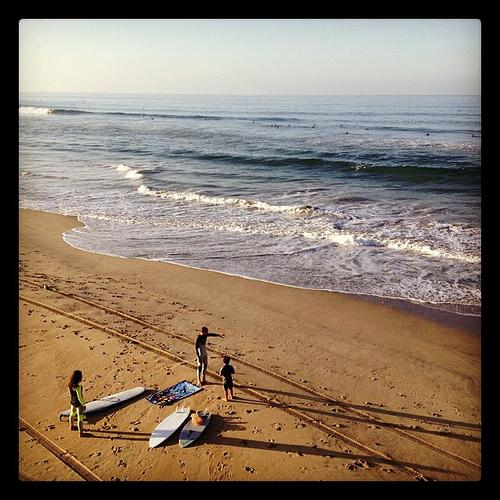Analyze the mood or sentiment of the image. The image evokes a relaxing and peaceful mood, with people enjoying a day at the beach amidst the beautiful natural setting. Count the total number of surfboards visible in the image. There are five surfboards in the image, including three white surfboards placed in the sand and two longer surfboards nearby. Identify the primary setting of the image. The image is set at a beach with a blue sky, clouds, sea water, and sand. Identify what the people are wearing while standing near the surfboard. One person is wearing a yellow wetsuit, another in a white and black wetsuit, and a child is wearing surfing clothes. Describe the interactions between the people and the surfboards. The three persons are standing near a surfboard, with a man talking to a child, and another person standing next to the towel near the surfboards. A person is pointing their arm towards the distance. What is happening in the ocean waters in the image? There are waves crashing in the sea water, birds in the calm ocean, and white waters coming into the shore with the tide. How many people can be seen on the beach? There are five people at the beach, including three standing near the surfboard, a person standing next to the towel, and a person standing near the two surfboards. Describe the scene involving the surfers and their surfboards. Three persons are standing near a surfboard with one surfer in a yellow wetsuit, another in a white and black wetsuit, and a little boy wearing surfing clothes. There are two white surfboards and a white surfboard in the sand nearby. What type of weather is shown in the image? It's a partly cloudy day with a blue sky and some clouds. What are the different objects that can be seen on the sand? There are surfboards, footprints, towel, a beach towel, a lone bird, and a little boy wearing surfing clothes on the sand. List all the objects in the image and their attributes. blue sky with clouds, surfboards in sand, sea water, waves, three persons, foot steps, yellow wetsuit surfer, white and black wetsuit surfer, birds in ocean, beach towel, little boy in surfing clothes, man's arm pointing. Locate the group of dolphins playfully swimming in the deeper part of the ocean. No, it's not mentioned in the image. Are there any texts visible in the image? If so, describe them. No, there are no texts visible in the image. Describe the different segments in the image according to their appearance. Sky, beach, ocean with waves, people with surfboards, footprints in the sand. Find out which object best describes the condition of the ocean in this image. The waves in the sea water and the white waters in the ocean. What kind of clothing are the people in the image wearing? Surfing clothes, wetsuits, casual beach attire. Describe the color and size attributes of the surfboards. White surfboards of various sizes, two primarily large ones in focus. Are there any unnatural occurrences or oddities within the image? No, there are no unnatural occurrences or oddities. Is the image clear and well-lit for comprehension? Yes, the image is clear and well-lit. What captions could be used to uniquely identify the surfboard in the sand? "a white surfboard in the sand", "the longest surfboard on the sand", "the item on the surfboard"  what object in the image conveys the most enjoyable and peaceful part The blue color sky with clouds conveys a peaceful atmosphere and the people with surfboards convey enjoyment. Identify the main actions of the people in the image. Standing, talking, pointing, holding surfboards. Describe the image with a single sentence. The image shows people and surfboards on a beach with footprints in the sand and blue sky with clouds above the sea. In what section of the image is the little boy wearing surfing clothes located? Bottom right section, coordinates X:214 Y:353 Width:31 Height:31. Which objects in the image are closest to the sea? Birds in the calm ocean, waves in the sea water, and the tide coming into the shore. What kind of emotions and mood does the scene in the image convey? Relaxation, enjoyment, and a peaceful mood. Are there any shadows in this image? There is no information about shadows in the image. what can you say about the clarity and brightness of the picture The clarity and brightness of the picture are good, making objects and details easily visible. Identify any objects interacting with each other in the image. Man talking to child, person standing next to surfboard, person standing next to towel, tide coming into the shore. 